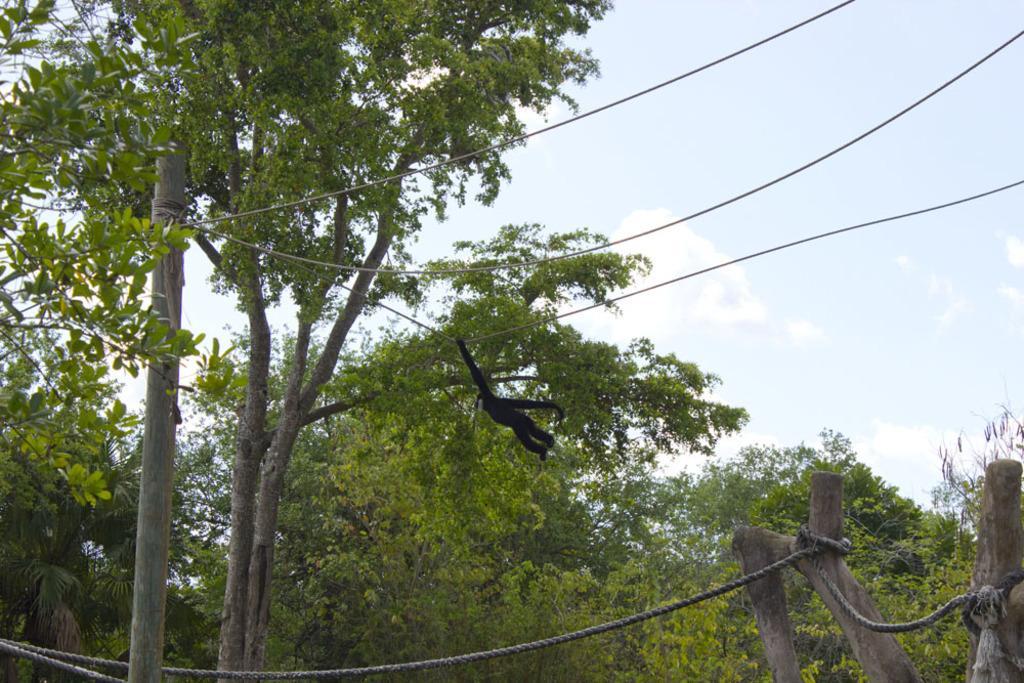Could you give a brief overview of what you see in this image? This is completely an outdoor picture. At the top of the picture we can see a sky with clouds. This is a tree and in front of the picture we can see a rope tied to the branch of a tree. 